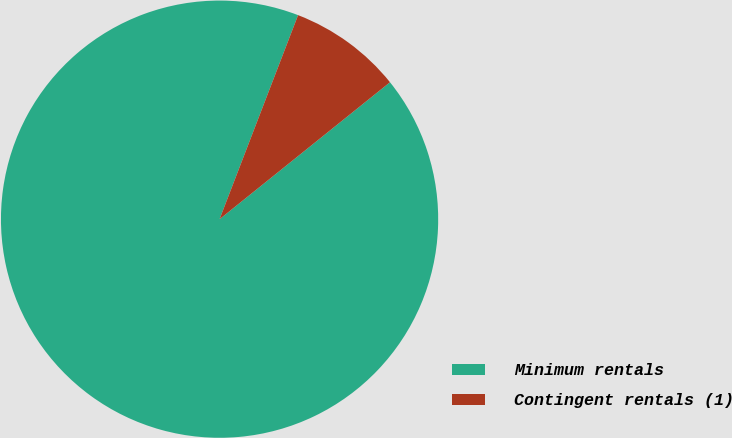<chart> <loc_0><loc_0><loc_500><loc_500><pie_chart><fcel>Minimum rentals<fcel>Contingent rentals (1)<nl><fcel>91.62%<fcel>8.38%<nl></chart> 